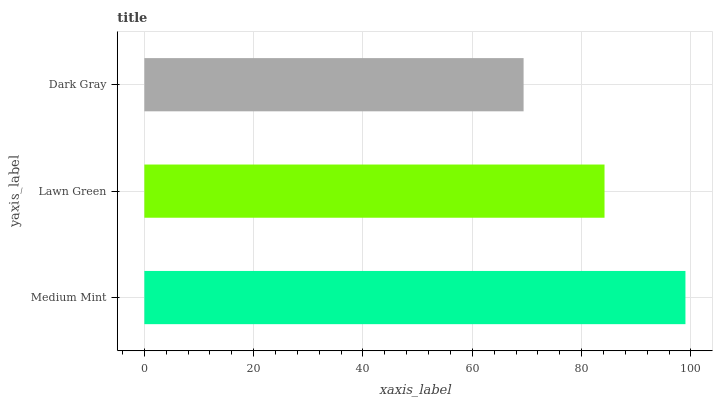Is Dark Gray the minimum?
Answer yes or no. Yes. Is Medium Mint the maximum?
Answer yes or no. Yes. Is Lawn Green the minimum?
Answer yes or no. No. Is Lawn Green the maximum?
Answer yes or no. No. Is Medium Mint greater than Lawn Green?
Answer yes or no. Yes. Is Lawn Green less than Medium Mint?
Answer yes or no. Yes. Is Lawn Green greater than Medium Mint?
Answer yes or no. No. Is Medium Mint less than Lawn Green?
Answer yes or no. No. Is Lawn Green the high median?
Answer yes or no. Yes. Is Lawn Green the low median?
Answer yes or no. Yes. Is Dark Gray the high median?
Answer yes or no. No. Is Dark Gray the low median?
Answer yes or no. No. 